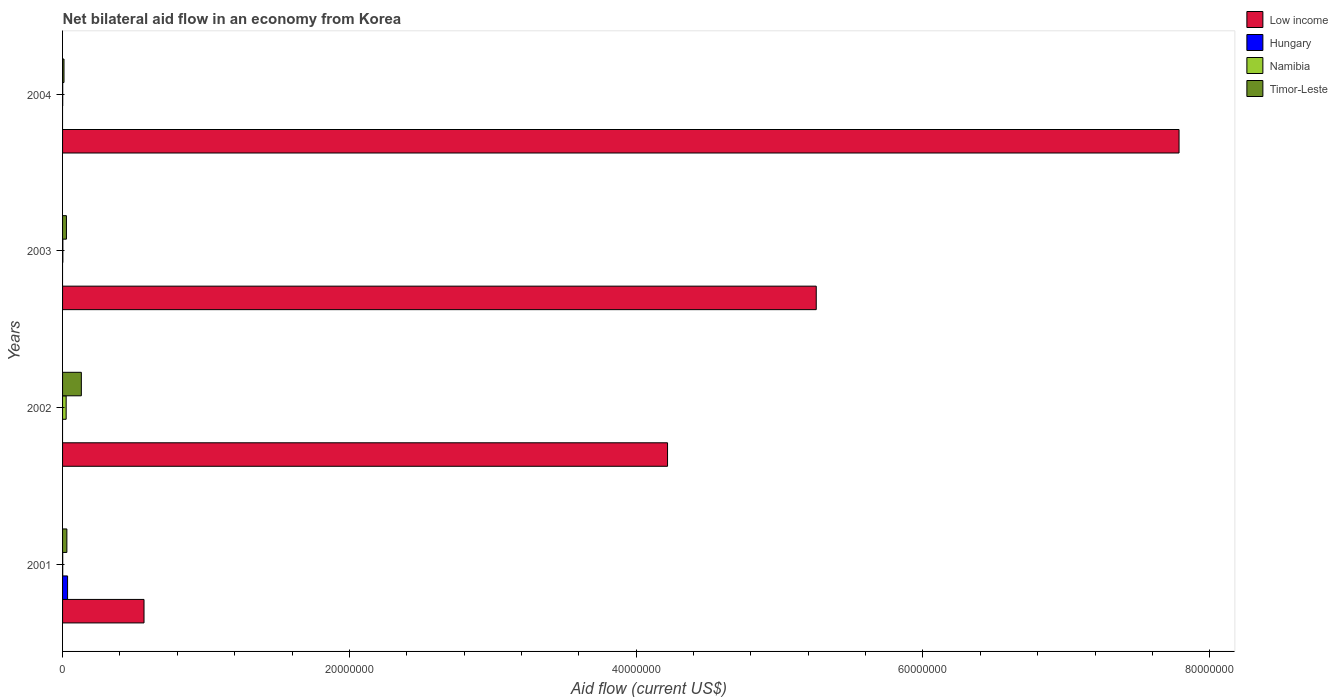How many different coloured bars are there?
Keep it short and to the point. 4. Are the number of bars per tick equal to the number of legend labels?
Your response must be concise. No. Are the number of bars on each tick of the Y-axis equal?
Make the answer very short. No. How many bars are there on the 3rd tick from the top?
Give a very brief answer. 3. How many bars are there on the 1st tick from the bottom?
Ensure brevity in your answer.  4. What is the label of the 3rd group of bars from the top?
Offer a very short reply. 2002. In how many cases, is the number of bars for a given year not equal to the number of legend labels?
Keep it short and to the point. 3. Across all years, what is the maximum net bilateral aid flow in Timor-Leste?
Your answer should be compact. 1.31e+06. What is the total net bilateral aid flow in Hungary in the graph?
Your response must be concise. 3.50e+05. What is the difference between the net bilateral aid flow in Low income in 2002 and that in 2003?
Your response must be concise. -1.04e+07. What is the difference between the net bilateral aid flow in Hungary in 2001 and the net bilateral aid flow in Timor-Leste in 2002?
Ensure brevity in your answer.  -9.60e+05. What is the average net bilateral aid flow in Low income per year?
Make the answer very short. 4.46e+07. In the year 2003, what is the difference between the net bilateral aid flow in Timor-Leste and net bilateral aid flow in Low income?
Give a very brief answer. -5.23e+07. In how many years, is the net bilateral aid flow in Timor-Leste greater than 28000000 US$?
Offer a very short reply. 0. What is the ratio of the net bilateral aid flow in Namibia in 2002 to that in 2004?
Provide a succinct answer. 25. What is the difference between the highest and the second highest net bilateral aid flow in Namibia?
Offer a terse response. 2.30e+05. What is the difference between the highest and the lowest net bilateral aid flow in Low income?
Keep it short and to the point. 7.22e+07. Is it the case that in every year, the sum of the net bilateral aid flow in Timor-Leste and net bilateral aid flow in Namibia is greater than the net bilateral aid flow in Low income?
Ensure brevity in your answer.  No. How many years are there in the graph?
Provide a short and direct response. 4. Are the values on the major ticks of X-axis written in scientific E-notation?
Provide a succinct answer. No. How are the legend labels stacked?
Make the answer very short. Vertical. What is the title of the graph?
Ensure brevity in your answer.  Net bilateral aid flow in an economy from Korea. What is the label or title of the Y-axis?
Provide a short and direct response. Years. What is the Aid flow (current US$) in Low income in 2001?
Ensure brevity in your answer.  5.68e+06. What is the Aid flow (current US$) in Timor-Leste in 2001?
Ensure brevity in your answer.  3.00e+05. What is the Aid flow (current US$) in Low income in 2002?
Your answer should be very brief. 4.22e+07. What is the Aid flow (current US$) of Namibia in 2002?
Your response must be concise. 2.50e+05. What is the Aid flow (current US$) of Timor-Leste in 2002?
Make the answer very short. 1.31e+06. What is the Aid flow (current US$) of Low income in 2003?
Provide a succinct answer. 5.26e+07. What is the Aid flow (current US$) of Namibia in 2003?
Ensure brevity in your answer.  2.00e+04. What is the Aid flow (current US$) in Timor-Leste in 2003?
Your answer should be compact. 2.70e+05. What is the Aid flow (current US$) in Low income in 2004?
Offer a terse response. 7.79e+07. What is the Aid flow (current US$) of Hungary in 2004?
Give a very brief answer. 0. What is the Aid flow (current US$) of Timor-Leste in 2004?
Keep it short and to the point. 1.00e+05. Across all years, what is the maximum Aid flow (current US$) in Low income?
Keep it short and to the point. 7.79e+07. Across all years, what is the maximum Aid flow (current US$) of Hungary?
Ensure brevity in your answer.  3.50e+05. Across all years, what is the maximum Aid flow (current US$) in Timor-Leste?
Your answer should be compact. 1.31e+06. Across all years, what is the minimum Aid flow (current US$) of Low income?
Provide a short and direct response. 5.68e+06. Across all years, what is the minimum Aid flow (current US$) of Namibia?
Keep it short and to the point. 10000. Across all years, what is the minimum Aid flow (current US$) of Timor-Leste?
Provide a succinct answer. 1.00e+05. What is the total Aid flow (current US$) of Low income in the graph?
Make the answer very short. 1.78e+08. What is the total Aid flow (current US$) of Hungary in the graph?
Keep it short and to the point. 3.50e+05. What is the total Aid flow (current US$) in Namibia in the graph?
Keep it short and to the point. 2.90e+05. What is the total Aid flow (current US$) of Timor-Leste in the graph?
Keep it short and to the point. 1.98e+06. What is the difference between the Aid flow (current US$) of Low income in 2001 and that in 2002?
Give a very brief answer. -3.65e+07. What is the difference between the Aid flow (current US$) of Namibia in 2001 and that in 2002?
Make the answer very short. -2.40e+05. What is the difference between the Aid flow (current US$) of Timor-Leste in 2001 and that in 2002?
Keep it short and to the point. -1.01e+06. What is the difference between the Aid flow (current US$) of Low income in 2001 and that in 2003?
Provide a succinct answer. -4.69e+07. What is the difference between the Aid flow (current US$) in Namibia in 2001 and that in 2003?
Provide a succinct answer. -10000. What is the difference between the Aid flow (current US$) in Timor-Leste in 2001 and that in 2003?
Offer a very short reply. 3.00e+04. What is the difference between the Aid flow (current US$) of Low income in 2001 and that in 2004?
Ensure brevity in your answer.  -7.22e+07. What is the difference between the Aid flow (current US$) in Namibia in 2001 and that in 2004?
Your answer should be very brief. 0. What is the difference between the Aid flow (current US$) in Low income in 2002 and that in 2003?
Offer a very short reply. -1.04e+07. What is the difference between the Aid flow (current US$) in Timor-Leste in 2002 and that in 2003?
Your answer should be compact. 1.04e+06. What is the difference between the Aid flow (current US$) in Low income in 2002 and that in 2004?
Give a very brief answer. -3.57e+07. What is the difference between the Aid flow (current US$) of Namibia in 2002 and that in 2004?
Offer a terse response. 2.40e+05. What is the difference between the Aid flow (current US$) of Timor-Leste in 2002 and that in 2004?
Your answer should be very brief. 1.21e+06. What is the difference between the Aid flow (current US$) in Low income in 2003 and that in 2004?
Ensure brevity in your answer.  -2.53e+07. What is the difference between the Aid flow (current US$) of Namibia in 2003 and that in 2004?
Make the answer very short. 10000. What is the difference between the Aid flow (current US$) in Timor-Leste in 2003 and that in 2004?
Your answer should be very brief. 1.70e+05. What is the difference between the Aid flow (current US$) in Low income in 2001 and the Aid flow (current US$) in Namibia in 2002?
Give a very brief answer. 5.43e+06. What is the difference between the Aid flow (current US$) in Low income in 2001 and the Aid flow (current US$) in Timor-Leste in 2002?
Offer a terse response. 4.37e+06. What is the difference between the Aid flow (current US$) of Hungary in 2001 and the Aid flow (current US$) of Namibia in 2002?
Make the answer very short. 1.00e+05. What is the difference between the Aid flow (current US$) of Hungary in 2001 and the Aid flow (current US$) of Timor-Leste in 2002?
Offer a terse response. -9.60e+05. What is the difference between the Aid flow (current US$) in Namibia in 2001 and the Aid flow (current US$) in Timor-Leste in 2002?
Your response must be concise. -1.30e+06. What is the difference between the Aid flow (current US$) of Low income in 2001 and the Aid flow (current US$) of Namibia in 2003?
Provide a short and direct response. 5.66e+06. What is the difference between the Aid flow (current US$) in Low income in 2001 and the Aid flow (current US$) in Timor-Leste in 2003?
Keep it short and to the point. 5.41e+06. What is the difference between the Aid flow (current US$) in Hungary in 2001 and the Aid flow (current US$) in Timor-Leste in 2003?
Provide a succinct answer. 8.00e+04. What is the difference between the Aid flow (current US$) in Namibia in 2001 and the Aid flow (current US$) in Timor-Leste in 2003?
Ensure brevity in your answer.  -2.60e+05. What is the difference between the Aid flow (current US$) in Low income in 2001 and the Aid flow (current US$) in Namibia in 2004?
Provide a succinct answer. 5.67e+06. What is the difference between the Aid flow (current US$) in Low income in 2001 and the Aid flow (current US$) in Timor-Leste in 2004?
Ensure brevity in your answer.  5.58e+06. What is the difference between the Aid flow (current US$) in Hungary in 2001 and the Aid flow (current US$) in Timor-Leste in 2004?
Your answer should be compact. 2.50e+05. What is the difference between the Aid flow (current US$) of Namibia in 2001 and the Aid flow (current US$) of Timor-Leste in 2004?
Offer a terse response. -9.00e+04. What is the difference between the Aid flow (current US$) in Low income in 2002 and the Aid flow (current US$) in Namibia in 2003?
Offer a terse response. 4.22e+07. What is the difference between the Aid flow (current US$) in Low income in 2002 and the Aid flow (current US$) in Timor-Leste in 2003?
Make the answer very short. 4.19e+07. What is the difference between the Aid flow (current US$) of Namibia in 2002 and the Aid flow (current US$) of Timor-Leste in 2003?
Make the answer very short. -2.00e+04. What is the difference between the Aid flow (current US$) in Low income in 2002 and the Aid flow (current US$) in Namibia in 2004?
Your response must be concise. 4.22e+07. What is the difference between the Aid flow (current US$) of Low income in 2002 and the Aid flow (current US$) of Timor-Leste in 2004?
Your answer should be compact. 4.21e+07. What is the difference between the Aid flow (current US$) in Namibia in 2002 and the Aid flow (current US$) in Timor-Leste in 2004?
Offer a terse response. 1.50e+05. What is the difference between the Aid flow (current US$) in Low income in 2003 and the Aid flow (current US$) in Namibia in 2004?
Ensure brevity in your answer.  5.26e+07. What is the difference between the Aid flow (current US$) of Low income in 2003 and the Aid flow (current US$) of Timor-Leste in 2004?
Give a very brief answer. 5.25e+07. What is the difference between the Aid flow (current US$) in Namibia in 2003 and the Aid flow (current US$) in Timor-Leste in 2004?
Your answer should be very brief. -8.00e+04. What is the average Aid flow (current US$) in Low income per year?
Your answer should be compact. 4.46e+07. What is the average Aid flow (current US$) of Hungary per year?
Your answer should be compact. 8.75e+04. What is the average Aid flow (current US$) of Namibia per year?
Your response must be concise. 7.25e+04. What is the average Aid flow (current US$) in Timor-Leste per year?
Provide a short and direct response. 4.95e+05. In the year 2001, what is the difference between the Aid flow (current US$) of Low income and Aid flow (current US$) of Hungary?
Give a very brief answer. 5.33e+06. In the year 2001, what is the difference between the Aid flow (current US$) in Low income and Aid flow (current US$) in Namibia?
Offer a very short reply. 5.67e+06. In the year 2001, what is the difference between the Aid flow (current US$) of Low income and Aid flow (current US$) of Timor-Leste?
Provide a short and direct response. 5.38e+06. In the year 2001, what is the difference between the Aid flow (current US$) in Namibia and Aid flow (current US$) in Timor-Leste?
Offer a terse response. -2.90e+05. In the year 2002, what is the difference between the Aid flow (current US$) of Low income and Aid flow (current US$) of Namibia?
Provide a short and direct response. 4.19e+07. In the year 2002, what is the difference between the Aid flow (current US$) of Low income and Aid flow (current US$) of Timor-Leste?
Your response must be concise. 4.09e+07. In the year 2002, what is the difference between the Aid flow (current US$) in Namibia and Aid flow (current US$) in Timor-Leste?
Offer a very short reply. -1.06e+06. In the year 2003, what is the difference between the Aid flow (current US$) of Low income and Aid flow (current US$) of Namibia?
Your answer should be compact. 5.25e+07. In the year 2003, what is the difference between the Aid flow (current US$) in Low income and Aid flow (current US$) in Timor-Leste?
Your answer should be compact. 5.23e+07. In the year 2003, what is the difference between the Aid flow (current US$) of Namibia and Aid flow (current US$) of Timor-Leste?
Your response must be concise. -2.50e+05. In the year 2004, what is the difference between the Aid flow (current US$) of Low income and Aid flow (current US$) of Namibia?
Ensure brevity in your answer.  7.78e+07. In the year 2004, what is the difference between the Aid flow (current US$) in Low income and Aid flow (current US$) in Timor-Leste?
Provide a succinct answer. 7.78e+07. In the year 2004, what is the difference between the Aid flow (current US$) of Namibia and Aid flow (current US$) of Timor-Leste?
Offer a terse response. -9.00e+04. What is the ratio of the Aid flow (current US$) of Low income in 2001 to that in 2002?
Your answer should be compact. 0.13. What is the ratio of the Aid flow (current US$) in Timor-Leste in 2001 to that in 2002?
Keep it short and to the point. 0.23. What is the ratio of the Aid flow (current US$) of Low income in 2001 to that in 2003?
Offer a very short reply. 0.11. What is the ratio of the Aid flow (current US$) in Timor-Leste in 2001 to that in 2003?
Ensure brevity in your answer.  1.11. What is the ratio of the Aid flow (current US$) in Low income in 2001 to that in 2004?
Keep it short and to the point. 0.07. What is the ratio of the Aid flow (current US$) in Namibia in 2001 to that in 2004?
Your answer should be very brief. 1. What is the ratio of the Aid flow (current US$) of Timor-Leste in 2001 to that in 2004?
Your response must be concise. 3. What is the ratio of the Aid flow (current US$) of Low income in 2002 to that in 2003?
Your response must be concise. 0.8. What is the ratio of the Aid flow (current US$) in Timor-Leste in 2002 to that in 2003?
Make the answer very short. 4.85. What is the ratio of the Aid flow (current US$) of Low income in 2002 to that in 2004?
Your answer should be compact. 0.54. What is the ratio of the Aid flow (current US$) in Namibia in 2002 to that in 2004?
Offer a very short reply. 25. What is the ratio of the Aid flow (current US$) of Timor-Leste in 2002 to that in 2004?
Your answer should be compact. 13.1. What is the ratio of the Aid flow (current US$) of Low income in 2003 to that in 2004?
Offer a very short reply. 0.68. What is the ratio of the Aid flow (current US$) in Namibia in 2003 to that in 2004?
Ensure brevity in your answer.  2. What is the ratio of the Aid flow (current US$) in Timor-Leste in 2003 to that in 2004?
Your answer should be very brief. 2.7. What is the difference between the highest and the second highest Aid flow (current US$) in Low income?
Give a very brief answer. 2.53e+07. What is the difference between the highest and the second highest Aid flow (current US$) in Timor-Leste?
Your response must be concise. 1.01e+06. What is the difference between the highest and the lowest Aid flow (current US$) of Low income?
Offer a terse response. 7.22e+07. What is the difference between the highest and the lowest Aid flow (current US$) of Timor-Leste?
Your response must be concise. 1.21e+06. 